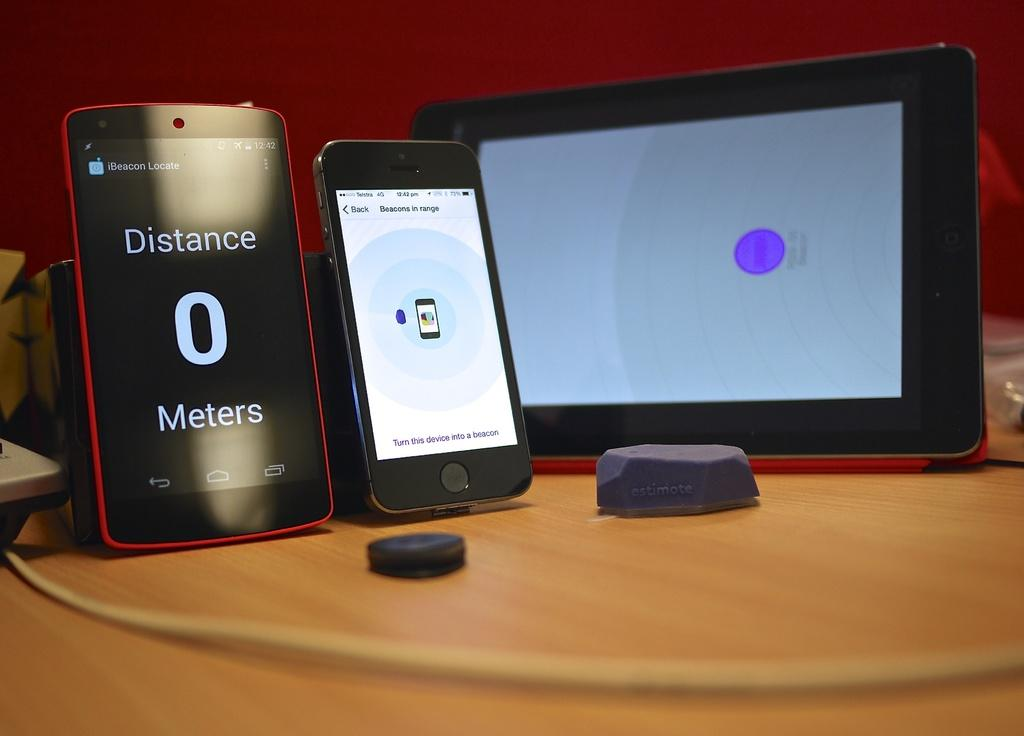What type of objects can be seen in the image? There are electronic gadgets in the image. What is connected to the electronic gadgets? There is a cable in the image. What surface are the electronic gadgets and cable placed on? There is a table in the image. What can be seen at the top of the image? The wall is visible at the top of the image. What type of paper is being used to set a new record in the image? There is no paper or record-setting activity present in the image. 